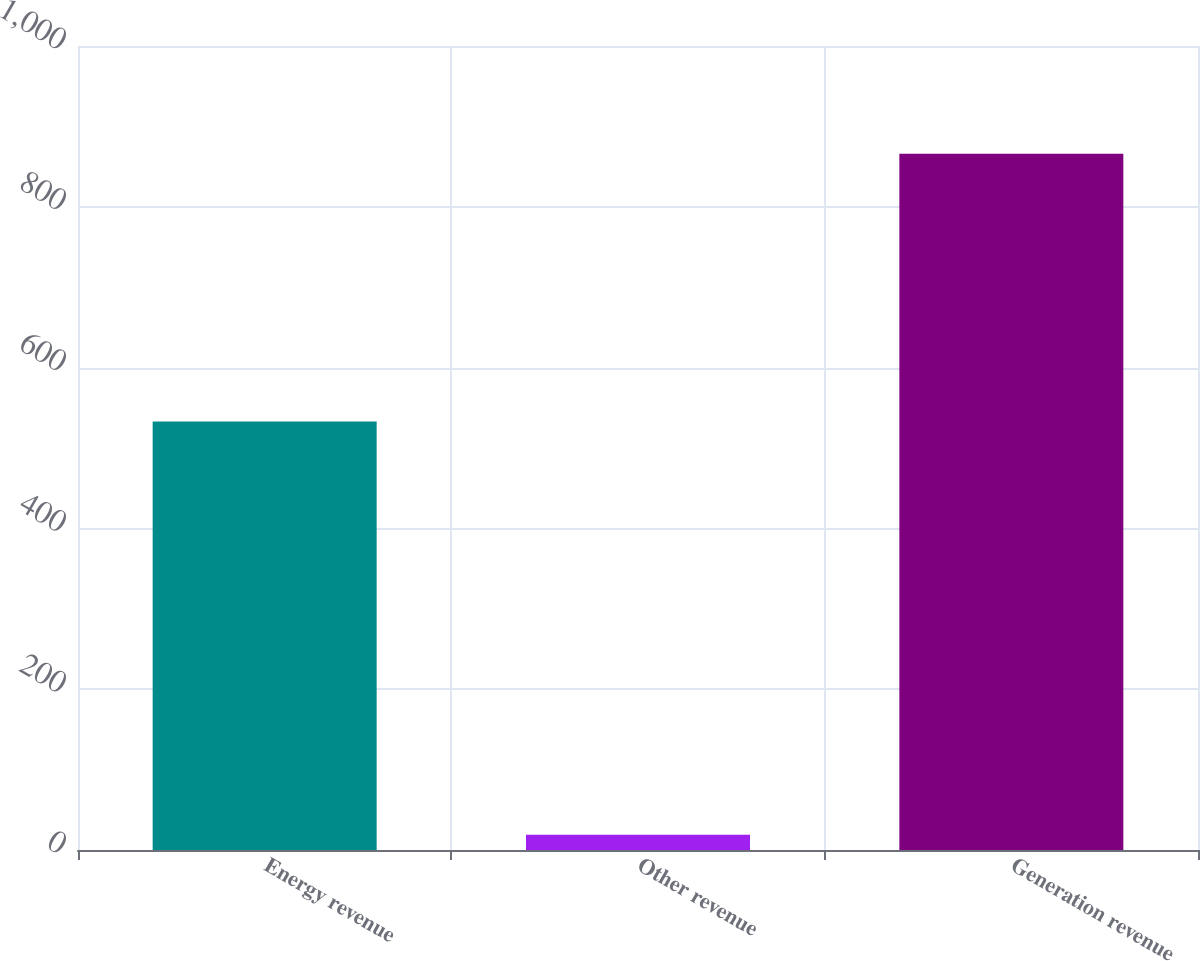Convert chart. <chart><loc_0><loc_0><loc_500><loc_500><bar_chart><fcel>Energy revenue<fcel>Other revenue<fcel>Generation revenue<nl><fcel>533<fcel>19<fcel>866<nl></chart> 